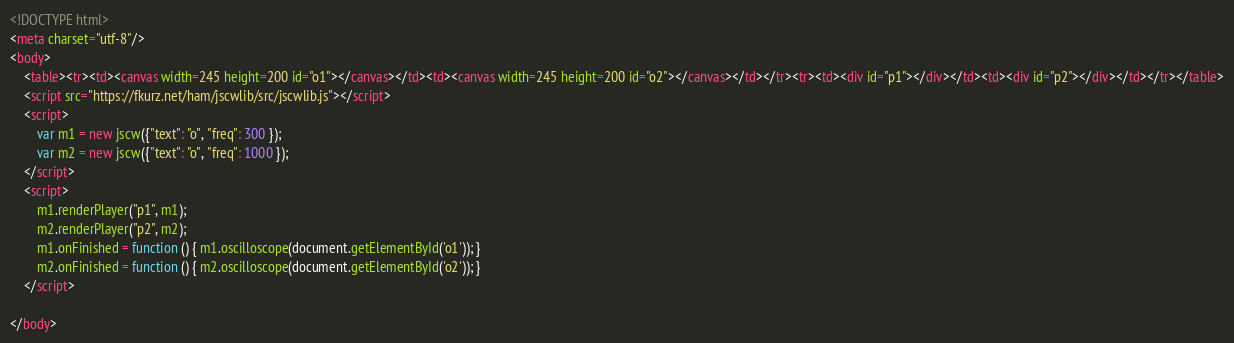Convert code to text. <code><loc_0><loc_0><loc_500><loc_500><_HTML_><!DOCTYPE html>
<meta charset="utf-8"/>
<body>
    <table><tr><td><canvas width=245 height=200 id="o1"></canvas></td><td><canvas width=245 height=200 id="o2"></canvas></td></tr><tr><td><div id="p1"></div></td><td><div id="p2"></div></td></tr></table>
    <script src="https://fkurz.net/ham/jscwlib/src/jscwlib.js"></script>
    <script>
        var m1 = new jscw({"text": "o", "freq": 300 });
        var m2 = new jscw({"text": "o", "freq": 1000 });
    </script>
    <script>
        m1.renderPlayer("p1", m1);
        m2.renderPlayer("p2", m2);
        m1.onFinished = function () { m1.oscilloscope(document.getElementById('o1')); }
        m2.onFinished = function () { m2.oscilloscope(document.getElementById('o2')); }
    </script>

</body>
</code> 